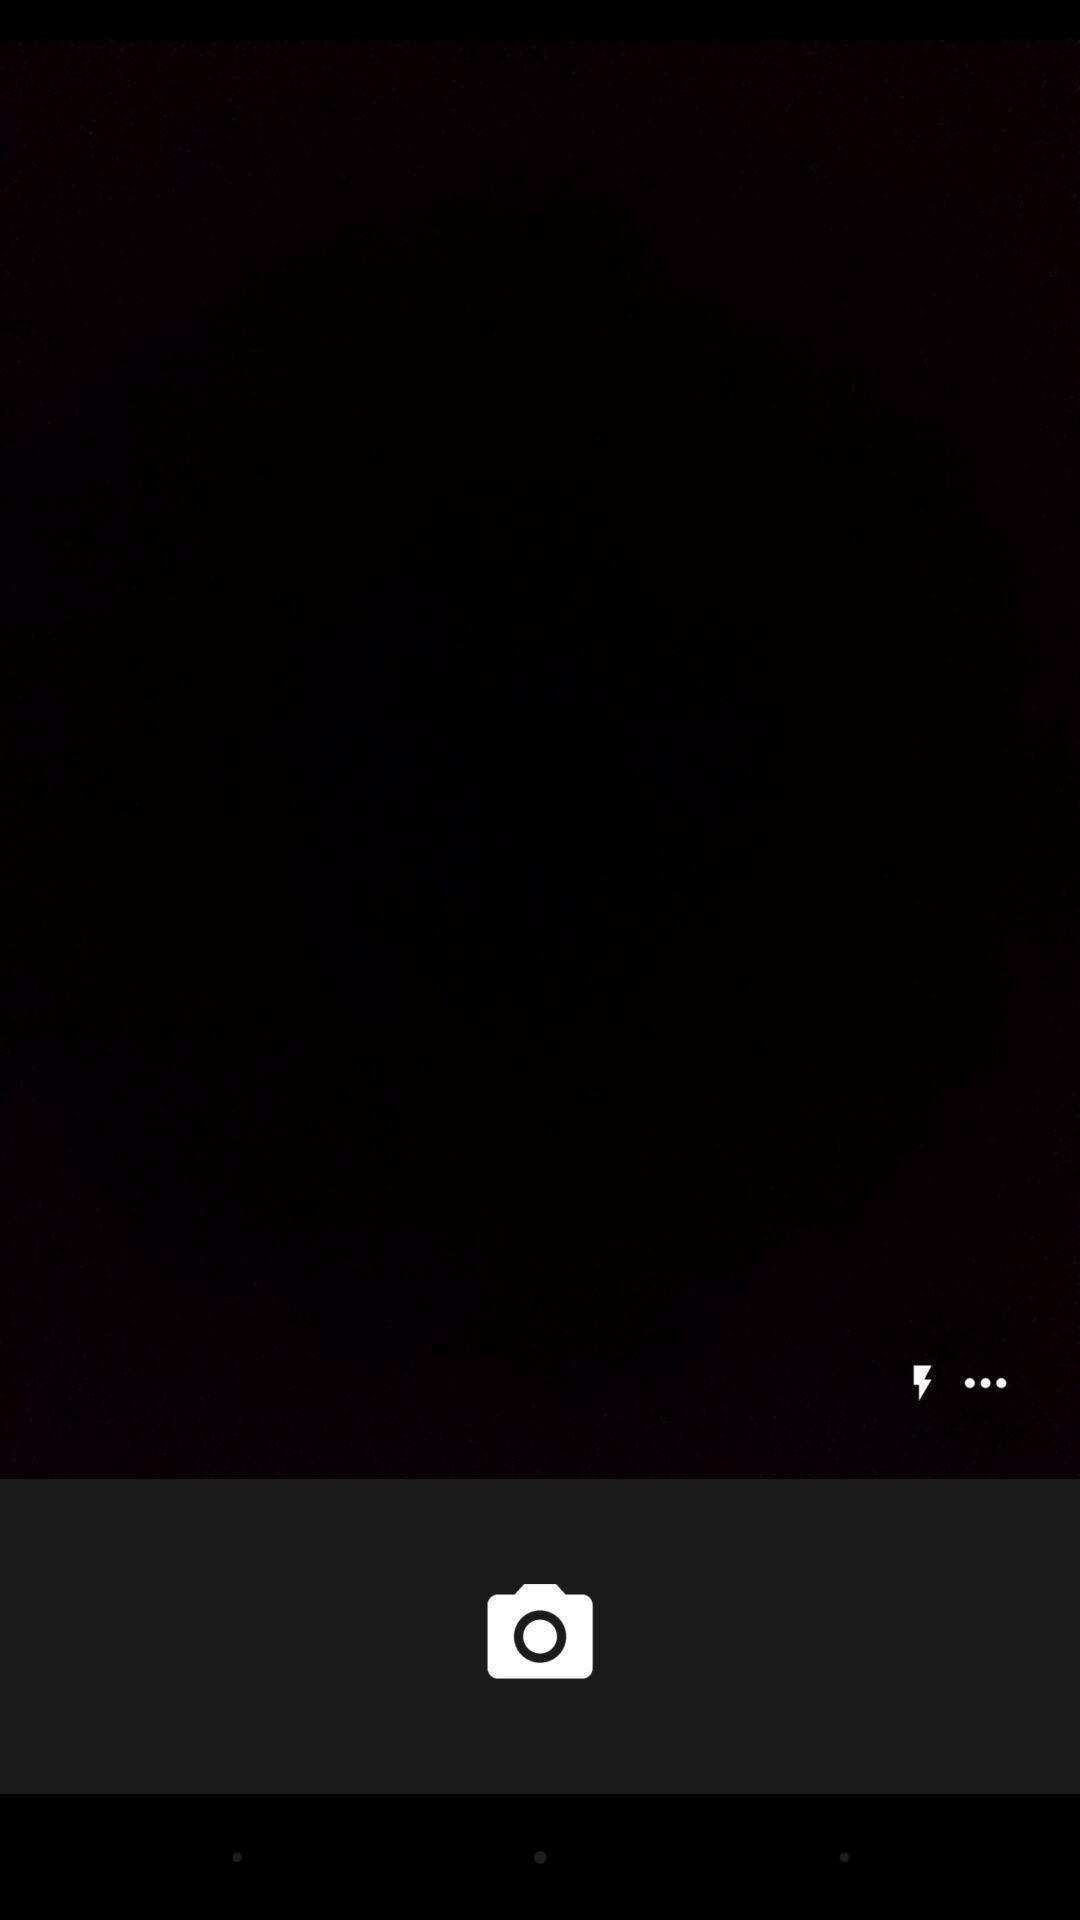Summarize the main components in this picture. Screen showing display with camera option. 